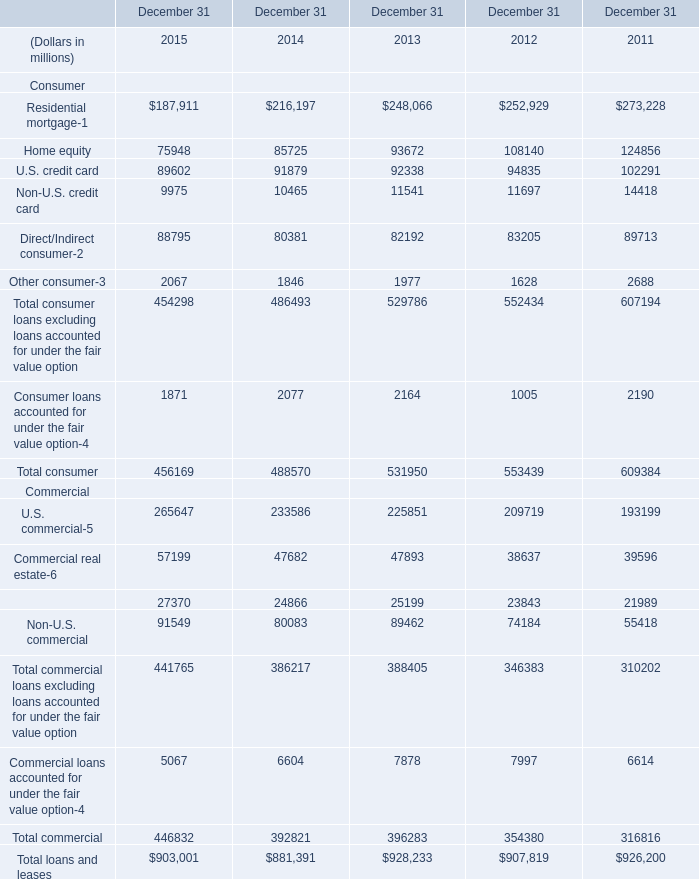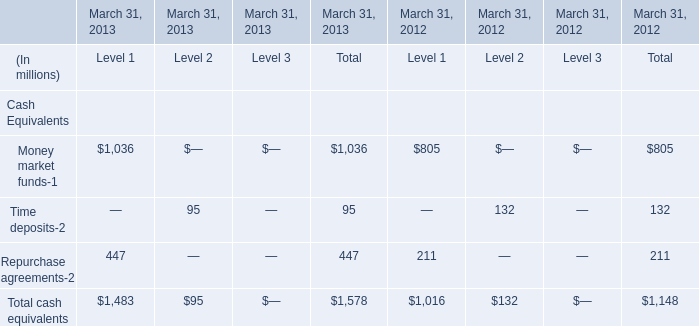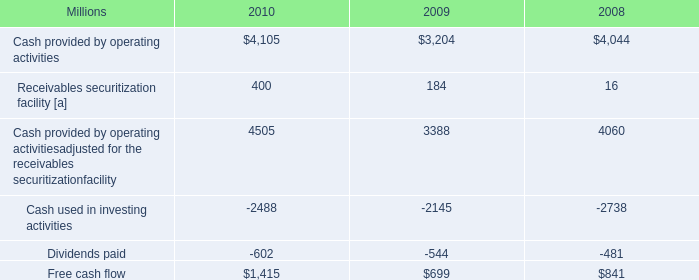What is the average amount of U.S. commercial Commercial of December 31 2015, and Cash used in investing activities of 2008 ? 
Computations: ((265647.0 + 2738.0) / 2)
Answer: 134192.5. 